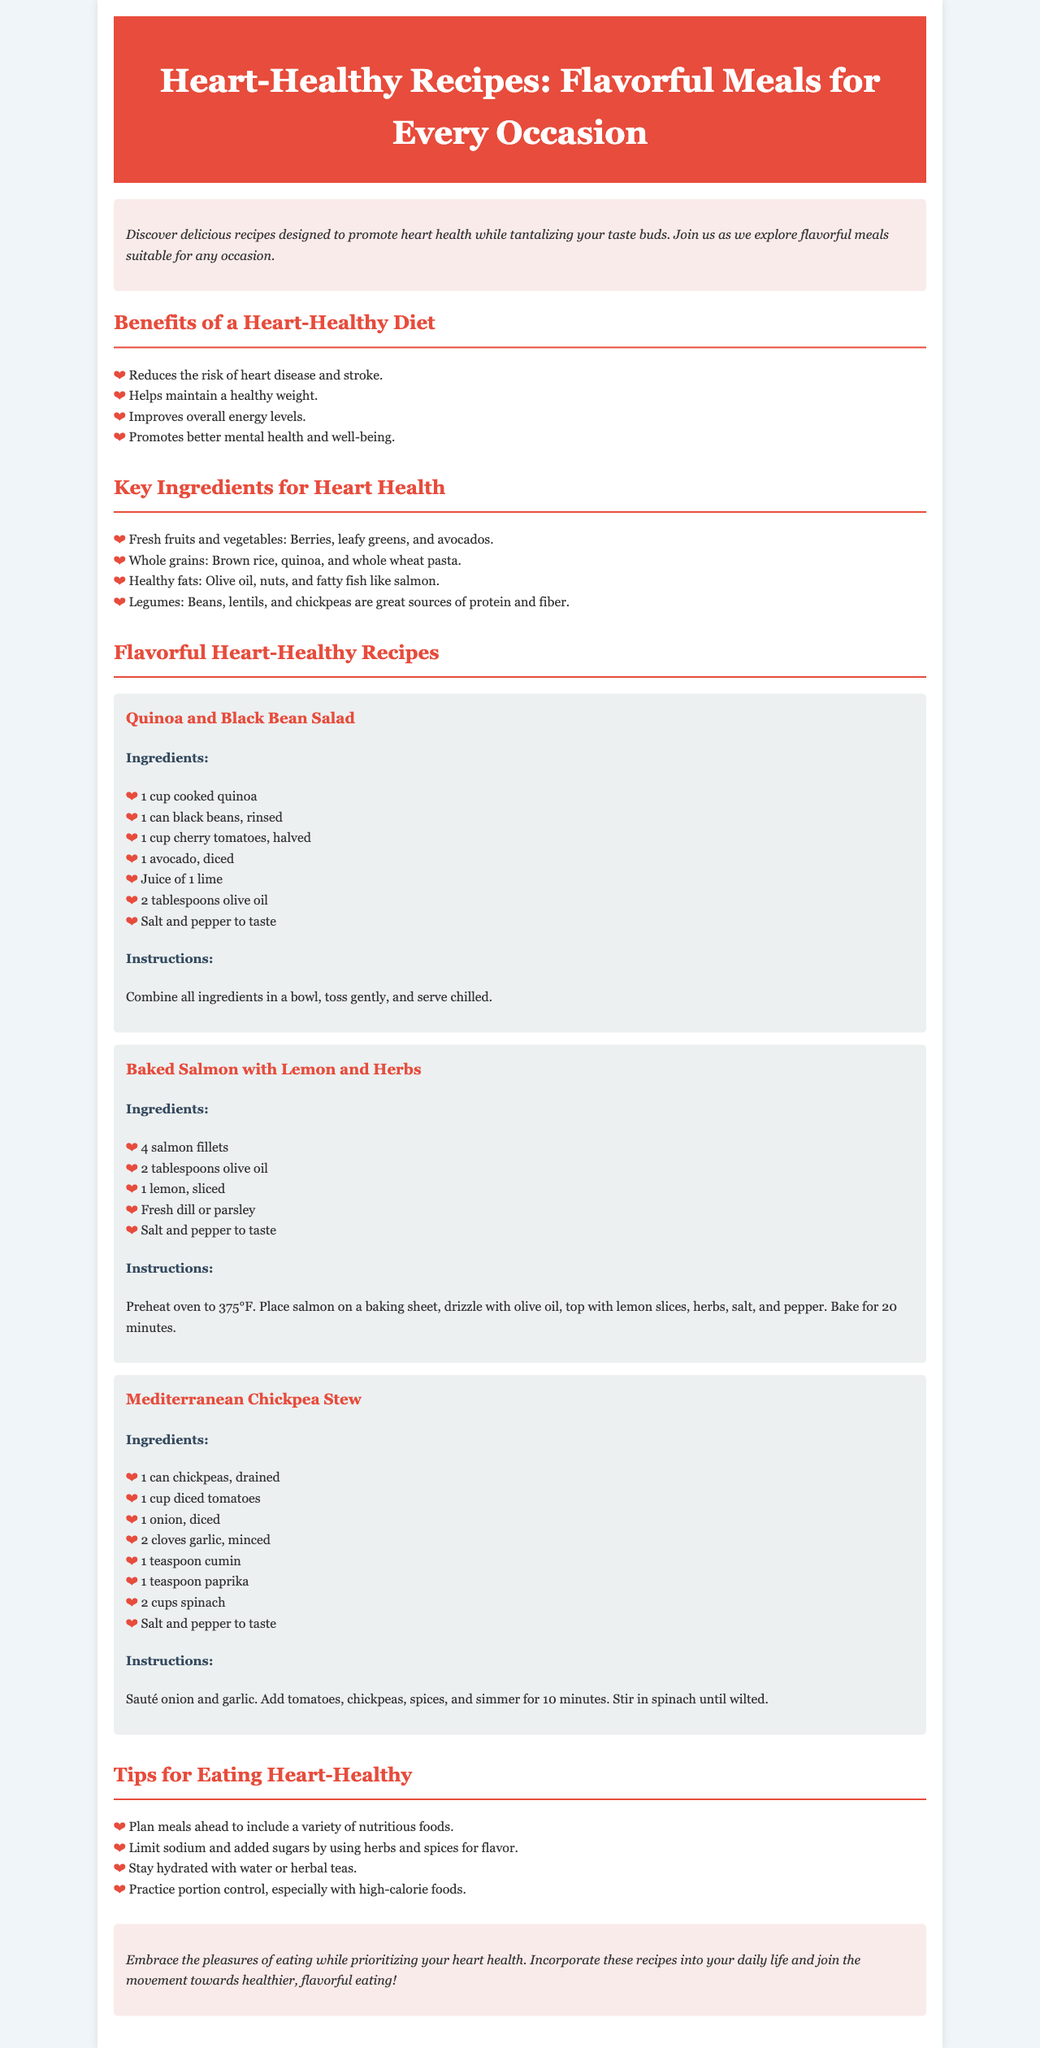What is the title of the brochure? The title is mentioned at the top of the document, which outlines the main topic of the brochure.
Answer: Heart-Healthy Recipes: Flavorful Meals for Every Occasion How many heart-healthy recipes are provided? The document lists three specific recipes under the section dedicated to flavorful heart-healthy recipes.
Answer: Three What ingredient is used in both the Baked Salmon and Quinoa and Black Bean Salad recipes? By reviewing the ingredients listed for both recipes, we can identify the common ingredient used in both meals.
Answer: Olive oil What is one benefit of a heart-healthy diet mentioned? The document lists several benefits, providing specific ones related to health.
Answer: Reduces the risk of heart disease and stroke How long should you bake the salmon? The cooking time for the salmon is specified in the instructions for that particular recipe.
Answer: 20 minutes What key ingredient is suggested for healthy fats? The document provides examples of healthy fats, where one ingredient stands out as commonly recommended.
Answer: Olive oil What is one tip for eating heart-healthy? The document provides a list of practical tips, one of which emphasizes planning for nutritious meals.
Answer: Plan meals ahead to include a variety of nutritious foods What type of diet do the recipes promote? The overall theme and purpose of the recipes are defined in the document's introduction and benefits sections.
Answer: Heart-healthy diet 